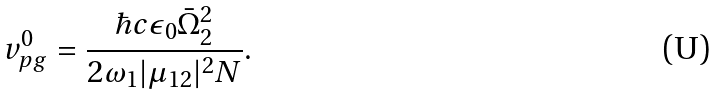Convert formula to latex. <formula><loc_0><loc_0><loc_500><loc_500>v ^ { 0 } _ { p g } = \frac { \hbar { c } \epsilon _ { 0 } \bar { \Omega } ^ { 2 } _ { 2 } } { 2 \omega _ { 1 } | \mu _ { 1 2 } | ^ { 2 } N } .</formula> 